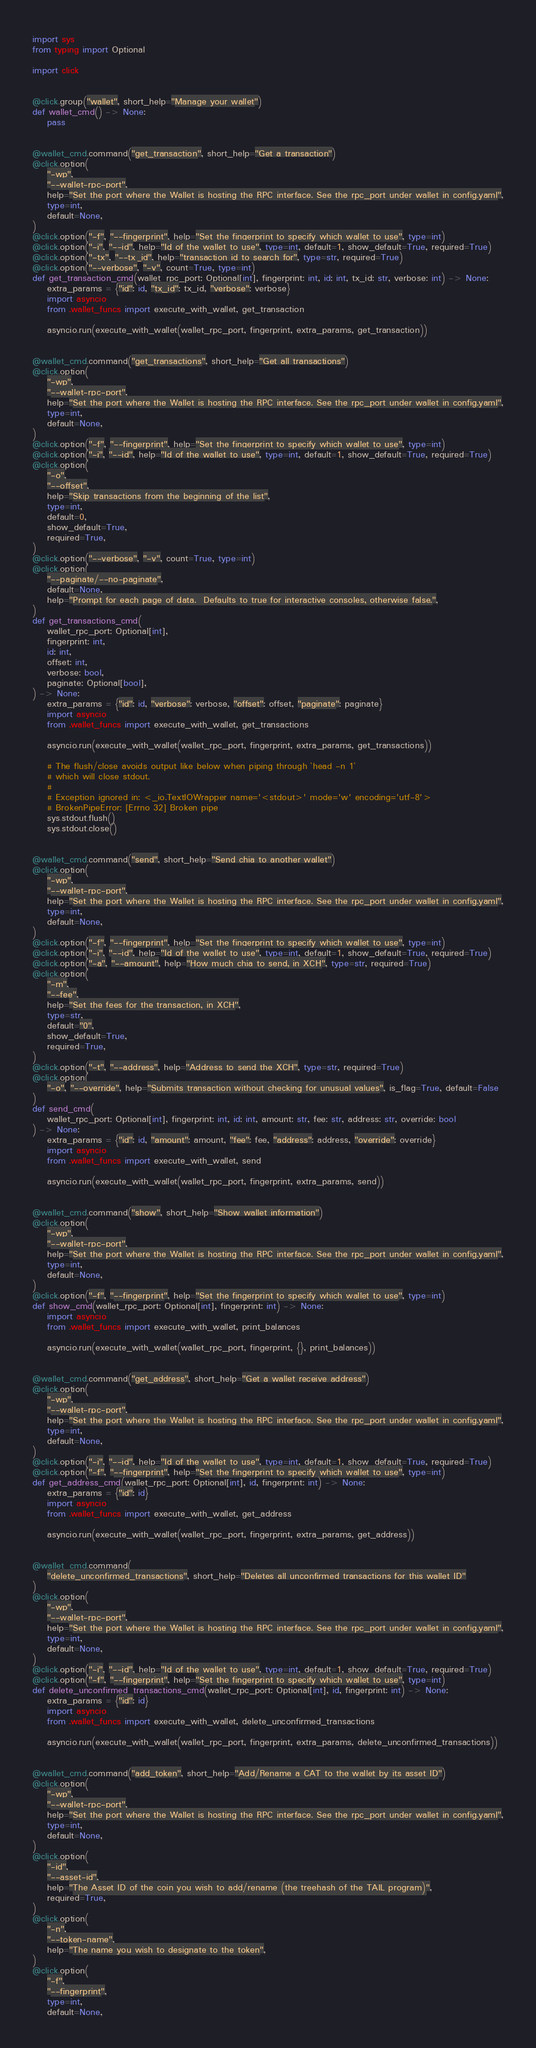Convert code to text. <code><loc_0><loc_0><loc_500><loc_500><_Python_>import sys
from typing import Optional

import click


@click.group("wallet", short_help="Manage your wallet")
def wallet_cmd() -> None:
    pass


@wallet_cmd.command("get_transaction", short_help="Get a transaction")
@click.option(
    "-wp",
    "--wallet-rpc-port",
    help="Set the port where the Wallet is hosting the RPC interface. See the rpc_port under wallet in config.yaml",
    type=int,
    default=None,
)
@click.option("-f", "--fingerprint", help="Set the fingerprint to specify which wallet to use", type=int)
@click.option("-i", "--id", help="Id of the wallet to use", type=int, default=1, show_default=True, required=True)
@click.option("-tx", "--tx_id", help="transaction id to search for", type=str, required=True)
@click.option("--verbose", "-v", count=True, type=int)
def get_transaction_cmd(wallet_rpc_port: Optional[int], fingerprint: int, id: int, tx_id: str, verbose: int) -> None:
    extra_params = {"id": id, "tx_id": tx_id, "verbose": verbose}
    import asyncio
    from .wallet_funcs import execute_with_wallet, get_transaction

    asyncio.run(execute_with_wallet(wallet_rpc_port, fingerprint, extra_params, get_transaction))


@wallet_cmd.command("get_transactions", short_help="Get all transactions")
@click.option(
    "-wp",
    "--wallet-rpc-port",
    help="Set the port where the Wallet is hosting the RPC interface. See the rpc_port under wallet in config.yaml",
    type=int,
    default=None,
)
@click.option("-f", "--fingerprint", help="Set the fingerprint to specify which wallet to use", type=int)
@click.option("-i", "--id", help="Id of the wallet to use", type=int, default=1, show_default=True, required=True)
@click.option(
    "-o",
    "--offset",
    help="Skip transactions from the beginning of the list",
    type=int,
    default=0,
    show_default=True,
    required=True,
)
@click.option("--verbose", "-v", count=True, type=int)
@click.option(
    "--paginate/--no-paginate",
    default=None,
    help="Prompt for each page of data.  Defaults to true for interactive consoles, otherwise false.",
)
def get_transactions_cmd(
    wallet_rpc_port: Optional[int],
    fingerprint: int,
    id: int,
    offset: int,
    verbose: bool,
    paginate: Optional[bool],
) -> None:
    extra_params = {"id": id, "verbose": verbose, "offset": offset, "paginate": paginate}
    import asyncio
    from .wallet_funcs import execute_with_wallet, get_transactions

    asyncio.run(execute_with_wallet(wallet_rpc_port, fingerprint, extra_params, get_transactions))

    # The flush/close avoids output like below when piping through `head -n 1`
    # which will close stdout.
    #
    # Exception ignored in: <_io.TextIOWrapper name='<stdout>' mode='w' encoding='utf-8'>
    # BrokenPipeError: [Errno 32] Broken pipe
    sys.stdout.flush()
    sys.stdout.close()


@wallet_cmd.command("send", short_help="Send chia to another wallet")
@click.option(
    "-wp",
    "--wallet-rpc-port",
    help="Set the port where the Wallet is hosting the RPC interface. See the rpc_port under wallet in config.yaml",
    type=int,
    default=None,
)
@click.option("-f", "--fingerprint", help="Set the fingerprint to specify which wallet to use", type=int)
@click.option("-i", "--id", help="Id of the wallet to use", type=int, default=1, show_default=True, required=True)
@click.option("-a", "--amount", help="How much chia to send, in XCH", type=str, required=True)
@click.option(
    "-m",
    "--fee",
    help="Set the fees for the transaction, in XCH",
    type=str,
    default="0",
    show_default=True,
    required=True,
)
@click.option("-t", "--address", help="Address to send the XCH", type=str, required=True)
@click.option(
    "-o", "--override", help="Submits transaction without checking for unusual values", is_flag=True, default=False
)
def send_cmd(
    wallet_rpc_port: Optional[int], fingerprint: int, id: int, amount: str, fee: str, address: str, override: bool
) -> None:
    extra_params = {"id": id, "amount": amount, "fee": fee, "address": address, "override": override}
    import asyncio
    from .wallet_funcs import execute_with_wallet, send

    asyncio.run(execute_with_wallet(wallet_rpc_port, fingerprint, extra_params, send))


@wallet_cmd.command("show", short_help="Show wallet information")
@click.option(
    "-wp",
    "--wallet-rpc-port",
    help="Set the port where the Wallet is hosting the RPC interface. See the rpc_port under wallet in config.yaml",
    type=int,
    default=None,
)
@click.option("-f", "--fingerprint", help="Set the fingerprint to specify which wallet to use", type=int)
def show_cmd(wallet_rpc_port: Optional[int], fingerprint: int) -> None:
    import asyncio
    from .wallet_funcs import execute_with_wallet, print_balances

    asyncio.run(execute_with_wallet(wallet_rpc_port, fingerprint, {}, print_balances))


@wallet_cmd.command("get_address", short_help="Get a wallet receive address")
@click.option(
    "-wp",
    "--wallet-rpc-port",
    help="Set the port where the Wallet is hosting the RPC interface. See the rpc_port under wallet in config.yaml",
    type=int,
    default=None,
)
@click.option("-i", "--id", help="Id of the wallet to use", type=int, default=1, show_default=True, required=True)
@click.option("-f", "--fingerprint", help="Set the fingerprint to specify which wallet to use", type=int)
def get_address_cmd(wallet_rpc_port: Optional[int], id, fingerprint: int) -> None:
    extra_params = {"id": id}
    import asyncio
    from .wallet_funcs import execute_with_wallet, get_address

    asyncio.run(execute_with_wallet(wallet_rpc_port, fingerprint, extra_params, get_address))


@wallet_cmd.command(
    "delete_unconfirmed_transactions", short_help="Deletes all unconfirmed transactions for this wallet ID"
)
@click.option(
    "-wp",
    "--wallet-rpc-port",
    help="Set the port where the Wallet is hosting the RPC interface. See the rpc_port under wallet in config.yaml",
    type=int,
    default=None,
)
@click.option("-i", "--id", help="Id of the wallet to use", type=int, default=1, show_default=True, required=True)
@click.option("-f", "--fingerprint", help="Set the fingerprint to specify which wallet to use", type=int)
def delete_unconfirmed_transactions_cmd(wallet_rpc_port: Optional[int], id, fingerprint: int) -> None:
    extra_params = {"id": id}
    import asyncio
    from .wallet_funcs import execute_with_wallet, delete_unconfirmed_transactions

    asyncio.run(execute_with_wallet(wallet_rpc_port, fingerprint, extra_params, delete_unconfirmed_transactions))


@wallet_cmd.command("add_token", short_help="Add/Rename a CAT to the wallet by its asset ID")
@click.option(
    "-wp",
    "--wallet-rpc-port",
    help="Set the port where the Wallet is hosting the RPC interface. See the rpc_port under wallet in config.yaml",
    type=int,
    default=None,
)
@click.option(
    "-id",
    "--asset-id",
    help="The Asset ID of the coin you wish to add/rename (the treehash of the TAIL program)",
    required=True,
)
@click.option(
    "-n",
    "--token-name",
    help="The name you wish to designate to the token",
)
@click.option(
    "-f",
    "--fingerprint",
    type=int,
    default=None,</code> 